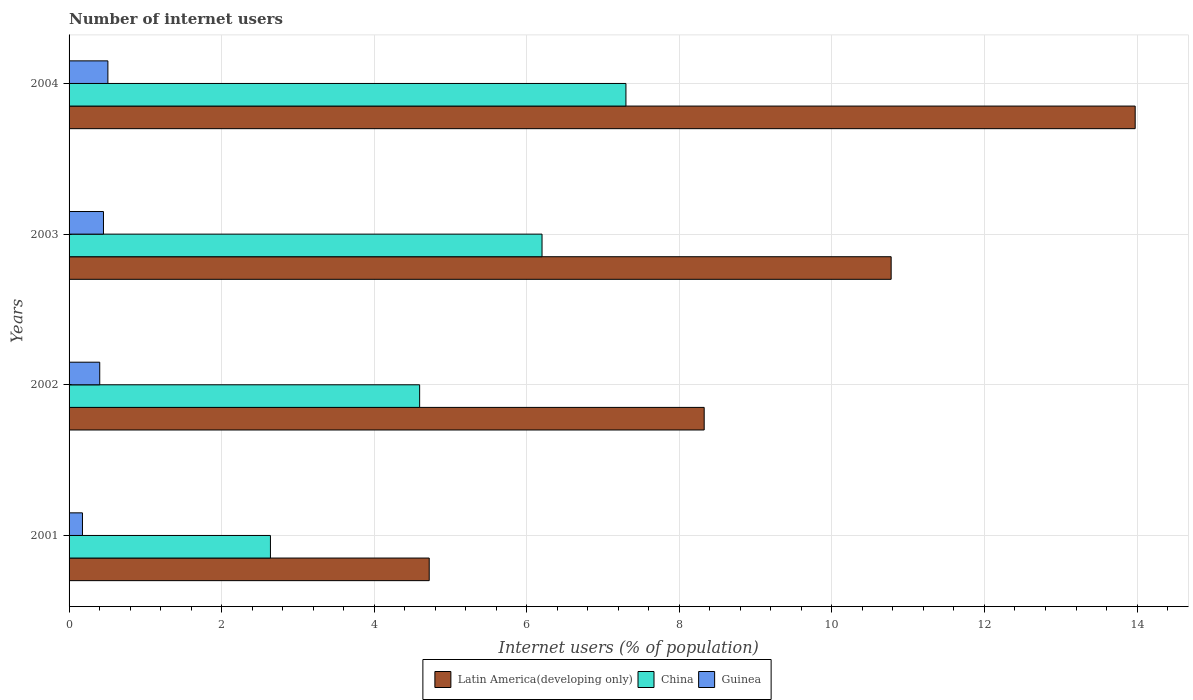How many different coloured bars are there?
Make the answer very short. 3. Are the number of bars per tick equal to the number of legend labels?
Provide a short and direct response. Yes. Are the number of bars on each tick of the Y-axis equal?
Keep it short and to the point. Yes. What is the number of internet users in Latin America(developing only) in 2001?
Provide a succinct answer. 4.72. Across all years, what is the maximum number of internet users in Latin America(developing only)?
Give a very brief answer. 13.98. Across all years, what is the minimum number of internet users in Guinea?
Provide a short and direct response. 0.18. In which year was the number of internet users in Guinea maximum?
Ensure brevity in your answer.  2004. In which year was the number of internet users in Guinea minimum?
Your answer should be very brief. 2001. What is the total number of internet users in Latin America(developing only) in the graph?
Offer a very short reply. 37.8. What is the difference between the number of internet users in Guinea in 2001 and that in 2004?
Provide a succinct answer. -0.33. What is the difference between the number of internet users in Latin America(developing only) in 2001 and the number of internet users in China in 2003?
Offer a very short reply. -1.48. What is the average number of internet users in Latin America(developing only) per year?
Offer a terse response. 9.45. In the year 2002, what is the difference between the number of internet users in China and number of internet users in Guinea?
Your answer should be compact. 4.19. What is the ratio of the number of internet users in Guinea in 2003 to that in 2004?
Your response must be concise. 0.89. Is the number of internet users in China in 2001 less than that in 2004?
Give a very brief answer. Yes. What is the difference between the highest and the second highest number of internet users in Guinea?
Provide a short and direct response. 0.06. What is the difference between the highest and the lowest number of internet users in Latin America(developing only)?
Provide a succinct answer. 9.25. In how many years, is the number of internet users in China greater than the average number of internet users in China taken over all years?
Your answer should be very brief. 2. Is the sum of the number of internet users in Guinea in 2003 and 2004 greater than the maximum number of internet users in China across all years?
Keep it short and to the point. No. What does the 3rd bar from the top in 2003 represents?
Give a very brief answer. Latin America(developing only). What does the 2nd bar from the bottom in 2002 represents?
Provide a short and direct response. China. How many years are there in the graph?
Offer a very short reply. 4. Does the graph contain any zero values?
Keep it short and to the point. No. Does the graph contain grids?
Your response must be concise. Yes. How are the legend labels stacked?
Offer a very short reply. Horizontal. What is the title of the graph?
Offer a very short reply. Number of internet users. What is the label or title of the X-axis?
Offer a very short reply. Internet users (% of population). What is the Internet users (% of population) of Latin America(developing only) in 2001?
Your answer should be compact. 4.72. What is the Internet users (% of population) of China in 2001?
Your answer should be very brief. 2.64. What is the Internet users (% of population) in Guinea in 2001?
Give a very brief answer. 0.18. What is the Internet users (% of population) of Latin America(developing only) in 2002?
Ensure brevity in your answer.  8.33. What is the Internet users (% of population) of China in 2002?
Offer a very short reply. 4.6. What is the Internet users (% of population) of Guinea in 2002?
Provide a succinct answer. 0.4. What is the Internet users (% of population) of Latin America(developing only) in 2003?
Make the answer very short. 10.78. What is the Internet users (% of population) of China in 2003?
Make the answer very short. 6.2. What is the Internet users (% of population) of Guinea in 2003?
Give a very brief answer. 0.45. What is the Internet users (% of population) in Latin America(developing only) in 2004?
Your response must be concise. 13.98. What is the Internet users (% of population) of Guinea in 2004?
Offer a very short reply. 0.51. Across all years, what is the maximum Internet users (% of population) in Latin America(developing only)?
Provide a short and direct response. 13.98. Across all years, what is the maximum Internet users (% of population) of Guinea?
Your answer should be very brief. 0.51. Across all years, what is the minimum Internet users (% of population) of Latin America(developing only)?
Give a very brief answer. 4.72. Across all years, what is the minimum Internet users (% of population) in China?
Offer a very short reply. 2.64. Across all years, what is the minimum Internet users (% of population) of Guinea?
Offer a terse response. 0.18. What is the total Internet users (% of population) in Latin America(developing only) in the graph?
Provide a succinct answer. 37.8. What is the total Internet users (% of population) in China in the graph?
Provide a succinct answer. 20.74. What is the total Internet users (% of population) of Guinea in the graph?
Provide a short and direct response. 1.54. What is the difference between the Internet users (% of population) of Latin America(developing only) in 2001 and that in 2002?
Give a very brief answer. -3.6. What is the difference between the Internet users (% of population) in China in 2001 and that in 2002?
Offer a terse response. -1.96. What is the difference between the Internet users (% of population) of Guinea in 2001 and that in 2002?
Provide a succinct answer. -0.23. What is the difference between the Internet users (% of population) in Latin America(developing only) in 2001 and that in 2003?
Your answer should be very brief. -6.06. What is the difference between the Internet users (% of population) in China in 2001 and that in 2003?
Your answer should be compact. -3.56. What is the difference between the Internet users (% of population) in Guinea in 2001 and that in 2003?
Provide a succinct answer. -0.28. What is the difference between the Internet users (% of population) of Latin America(developing only) in 2001 and that in 2004?
Your answer should be very brief. -9.25. What is the difference between the Internet users (% of population) in China in 2001 and that in 2004?
Your answer should be compact. -4.66. What is the difference between the Internet users (% of population) of Latin America(developing only) in 2002 and that in 2003?
Your response must be concise. -2.45. What is the difference between the Internet users (% of population) in China in 2002 and that in 2003?
Your answer should be very brief. -1.6. What is the difference between the Internet users (% of population) of Guinea in 2002 and that in 2003?
Your response must be concise. -0.05. What is the difference between the Internet users (% of population) in Latin America(developing only) in 2002 and that in 2004?
Give a very brief answer. -5.65. What is the difference between the Internet users (% of population) in China in 2002 and that in 2004?
Your response must be concise. -2.7. What is the difference between the Internet users (% of population) of Guinea in 2002 and that in 2004?
Your response must be concise. -0.11. What is the difference between the Internet users (% of population) in Latin America(developing only) in 2003 and that in 2004?
Your answer should be compact. -3.2. What is the difference between the Internet users (% of population) in China in 2003 and that in 2004?
Keep it short and to the point. -1.1. What is the difference between the Internet users (% of population) in Guinea in 2003 and that in 2004?
Your answer should be compact. -0.06. What is the difference between the Internet users (% of population) in Latin America(developing only) in 2001 and the Internet users (% of population) in China in 2002?
Ensure brevity in your answer.  0.13. What is the difference between the Internet users (% of population) in Latin America(developing only) in 2001 and the Internet users (% of population) in Guinea in 2002?
Offer a terse response. 4.32. What is the difference between the Internet users (% of population) of China in 2001 and the Internet users (% of population) of Guinea in 2002?
Offer a terse response. 2.24. What is the difference between the Internet users (% of population) in Latin America(developing only) in 2001 and the Internet users (% of population) in China in 2003?
Provide a succinct answer. -1.48. What is the difference between the Internet users (% of population) in Latin America(developing only) in 2001 and the Internet users (% of population) in Guinea in 2003?
Offer a very short reply. 4.27. What is the difference between the Internet users (% of population) in China in 2001 and the Internet users (% of population) in Guinea in 2003?
Offer a terse response. 2.19. What is the difference between the Internet users (% of population) in Latin America(developing only) in 2001 and the Internet users (% of population) in China in 2004?
Your answer should be compact. -2.58. What is the difference between the Internet users (% of population) of Latin America(developing only) in 2001 and the Internet users (% of population) of Guinea in 2004?
Keep it short and to the point. 4.21. What is the difference between the Internet users (% of population) in China in 2001 and the Internet users (% of population) in Guinea in 2004?
Your response must be concise. 2.13. What is the difference between the Internet users (% of population) of Latin America(developing only) in 2002 and the Internet users (% of population) of China in 2003?
Your answer should be very brief. 2.13. What is the difference between the Internet users (% of population) in Latin America(developing only) in 2002 and the Internet users (% of population) in Guinea in 2003?
Provide a short and direct response. 7.87. What is the difference between the Internet users (% of population) of China in 2002 and the Internet users (% of population) of Guinea in 2003?
Ensure brevity in your answer.  4.14. What is the difference between the Internet users (% of population) of Latin America(developing only) in 2002 and the Internet users (% of population) of China in 2004?
Your answer should be very brief. 1.03. What is the difference between the Internet users (% of population) of Latin America(developing only) in 2002 and the Internet users (% of population) of Guinea in 2004?
Provide a succinct answer. 7.82. What is the difference between the Internet users (% of population) in China in 2002 and the Internet users (% of population) in Guinea in 2004?
Make the answer very short. 4.09. What is the difference between the Internet users (% of population) of Latin America(developing only) in 2003 and the Internet users (% of population) of China in 2004?
Provide a succinct answer. 3.48. What is the difference between the Internet users (% of population) of Latin America(developing only) in 2003 and the Internet users (% of population) of Guinea in 2004?
Offer a terse response. 10.27. What is the difference between the Internet users (% of population) of China in 2003 and the Internet users (% of population) of Guinea in 2004?
Offer a very short reply. 5.69. What is the average Internet users (% of population) in Latin America(developing only) per year?
Your answer should be compact. 9.45. What is the average Internet users (% of population) of China per year?
Offer a very short reply. 5.18. What is the average Internet users (% of population) in Guinea per year?
Ensure brevity in your answer.  0.38. In the year 2001, what is the difference between the Internet users (% of population) in Latin America(developing only) and Internet users (% of population) in China?
Offer a very short reply. 2.08. In the year 2001, what is the difference between the Internet users (% of population) in Latin America(developing only) and Internet users (% of population) in Guinea?
Provide a succinct answer. 4.55. In the year 2001, what is the difference between the Internet users (% of population) in China and Internet users (% of population) in Guinea?
Provide a short and direct response. 2.46. In the year 2002, what is the difference between the Internet users (% of population) of Latin America(developing only) and Internet users (% of population) of China?
Give a very brief answer. 3.73. In the year 2002, what is the difference between the Internet users (% of population) in Latin America(developing only) and Internet users (% of population) in Guinea?
Offer a terse response. 7.92. In the year 2002, what is the difference between the Internet users (% of population) in China and Internet users (% of population) in Guinea?
Offer a terse response. 4.19. In the year 2003, what is the difference between the Internet users (% of population) in Latin America(developing only) and Internet users (% of population) in China?
Your answer should be very brief. 4.58. In the year 2003, what is the difference between the Internet users (% of population) in Latin America(developing only) and Internet users (% of population) in Guinea?
Your response must be concise. 10.33. In the year 2003, what is the difference between the Internet users (% of population) in China and Internet users (% of population) in Guinea?
Keep it short and to the point. 5.75. In the year 2004, what is the difference between the Internet users (% of population) in Latin America(developing only) and Internet users (% of population) in China?
Provide a short and direct response. 6.68. In the year 2004, what is the difference between the Internet users (% of population) in Latin America(developing only) and Internet users (% of population) in Guinea?
Ensure brevity in your answer.  13.47. In the year 2004, what is the difference between the Internet users (% of population) of China and Internet users (% of population) of Guinea?
Your response must be concise. 6.79. What is the ratio of the Internet users (% of population) of Latin America(developing only) in 2001 to that in 2002?
Your answer should be very brief. 0.57. What is the ratio of the Internet users (% of population) of China in 2001 to that in 2002?
Make the answer very short. 0.57. What is the ratio of the Internet users (% of population) in Guinea in 2001 to that in 2002?
Your answer should be very brief. 0.44. What is the ratio of the Internet users (% of population) in Latin America(developing only) in 2001 to that in 2003?
Offer a terse response. 0.44. What is the ratio of the Internet users (% of population) in China in 2001 to that in 2003?
Your answer should be compact. 0.43. What is the ratio of the Internet users (% of population) in Guinea in 2001 to that in 2003?
Give a very brief answer. 0.39. What is the ratio of the Internet users (% of population) of Latin America(developing only) in 2001 to that in 2004?
Your answer should be very brief. 0.34. What is the ratio of the Internet users (% of population) in China in 2001 to that in 2004?
Make the answer very short. 0.36. What is the ratio of the Internet users (% of population) of Guinea in 2001 to that in 2004?
Your response must be concise. 0.34. What is the ratio of the Internet users (% of population) in Latin America(developing only) in 2002 to that in 2003?
Offer a terse response. 0.77. What is the ratio of the Internet users (% of population) of China in 2002 to that in 2003?
Make the answer very short. 0.74. What is the ratio of the Internet users (% of population) of Guinea in 2002 to that in 2003?
Your answer should be compact. 0.89. What is the ratio of the Internet users (% of population) of Latin America(developing only) in 2002 to that in 2004?
Offer a terse response. 0.6. What is the ratio of the Internet users (% of population) of China in 2002 to that in 2004?
Give a very brief answer. 0.63. What is the ratio of the Internet users (% of population) in Guinea in 2002 to that in 2004?
Provide a succinct answer. 0.79. What is the ratio of the Internet users (% of population) of Latin America(developing only) in 2003 to that in 2004?
Your answer should be very brief. 0.77. What is the ratio of the Internet users (% of population) in China in 2003 to that in 2004?
Ensure brevity in your answer.  0.85. What is the ratio of the Internet users (% of population) in Guinea in 2003 to that in 2004?
Give a very brief answer. 0.89. What is the difference between the highest and the second highest Internet users (% of population) in Latin America(developing only)?
Provide a succinct answer. 3.2. What is the difference between the highest and the second highest Internet users (% of population) of Guinea?
Ensure brevity in your answer.  0.06. What is the difference between the highest and the lowest Internet users (% of population) in Latin America(developing only)?
Your response must be concise. 9.25. What is the difference between the highest and the lowest Internet users (% of population) of China?
Your answer should be compact. 4.66. What is the difference between the highest and the lowest Internet users (% of population) in Guinea?
Provide a succinct answer. 0.33. 